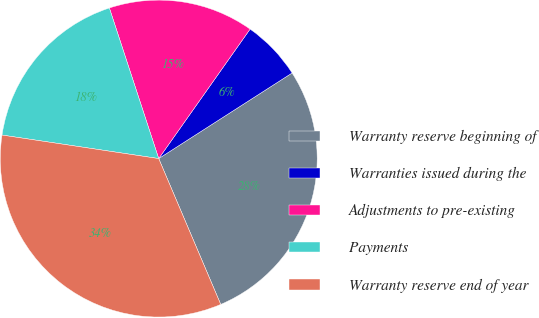<chart> <loc_0><loc_0><loc_500><loc_500><pie_chart><fcel>Warranty reserve beginning of<fcel>Warranties issued during the<fcel>Adjustments to pre-existing<fcel>Payments<fcel>Warranty reserve end of year<nl><fcel>27.68%<fcel>6.14%<fcel>14.82%<fcel>17.59%<fcel>33.77%<nl></chart> 